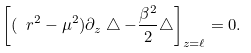<formula> <loc_0><loc_0><loc_500><loc_500>\left [ ( \ r ^ { 2 } - \mu ^ { 2 } ) \partial _ { z } \bigtriangleup - \frac { \beta ^ { 2 } } { 2 } \bigtriangleup \right ] _ { z = \ell } = 0 .</formula> 